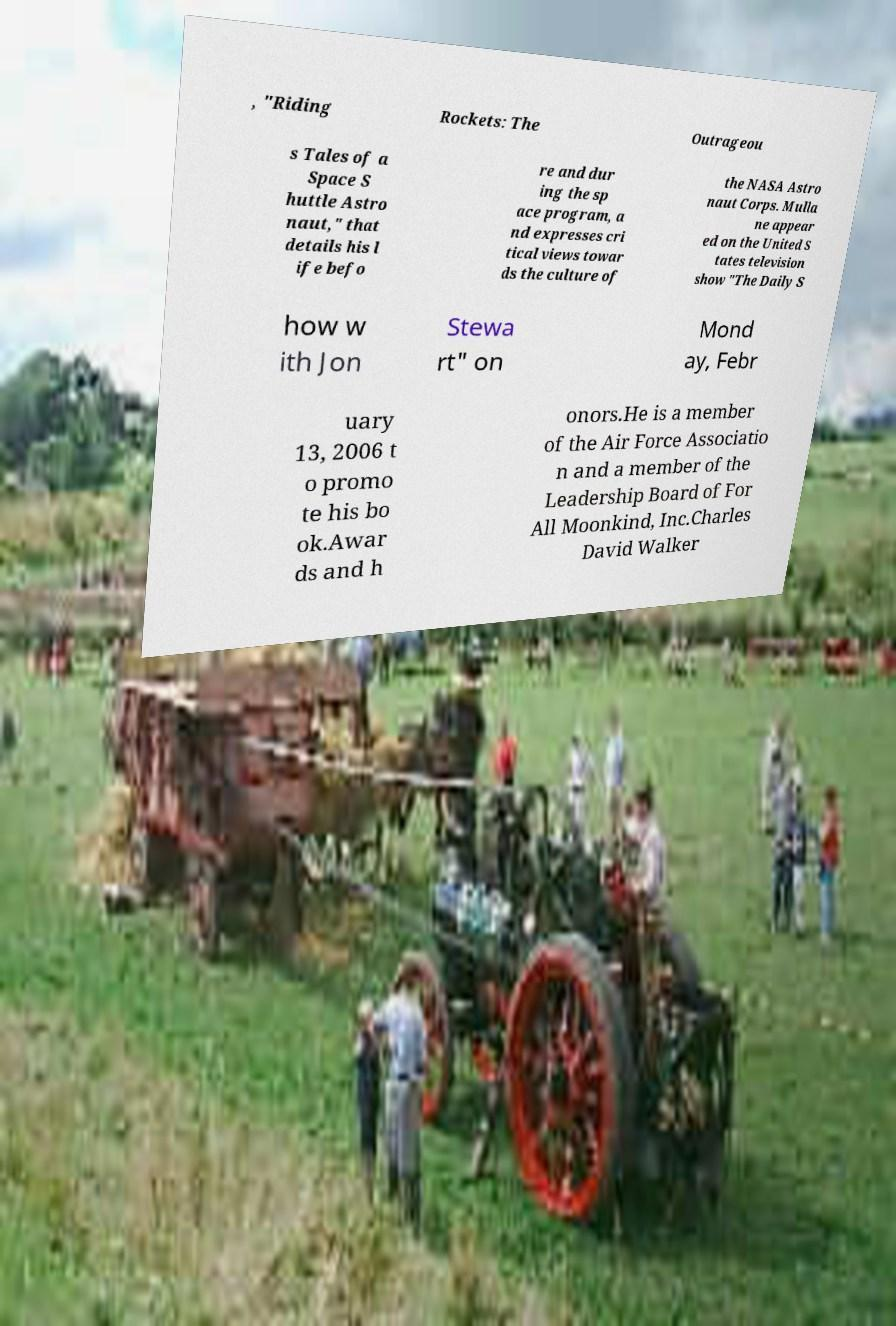There's text embedded in this image that I need extracted. Can you transcribe it verbatim? , "Riding Rockets: The Outrageou s Tales of a Space S huttle Astro naut," that details his l ife befo re and dur ing the sp ace program, a nd expresses cri tical views towar ds the culture of the NASA Astro naut Corps. Mulla ne appear ed on the United S tates television show "The Daily S how w ith Jon Stewa rt" on Mond ay, Febr uary 13, 2006 t o promo te his bo ok.Awar ds and h onors.He is a member of the Air Force Associatio n and a member of the Leadership Board of For All Moonkind, Inc.Charles David Walker 